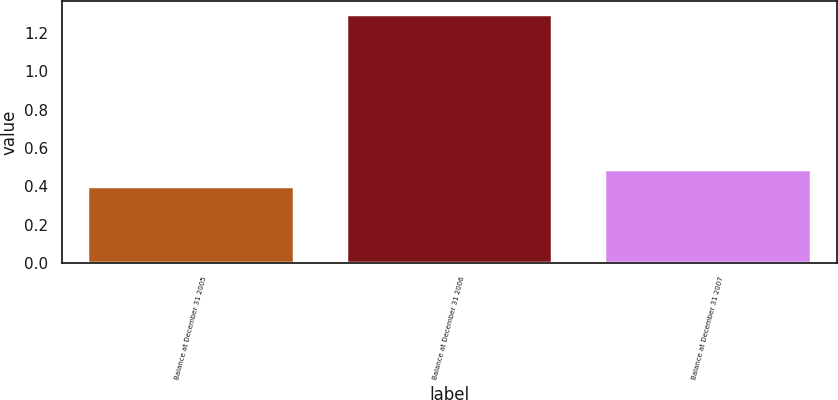<chart> <loc_0><loc_0><loc_500><loc_500><bar_chart><fcel>Balance at December 31 2005<fcel>Balance at December 31 2006<fcel>Balance at December 31 2007<nl><fcel>0.4<fcel>1.3<fcel>0.49<nl></chart> 